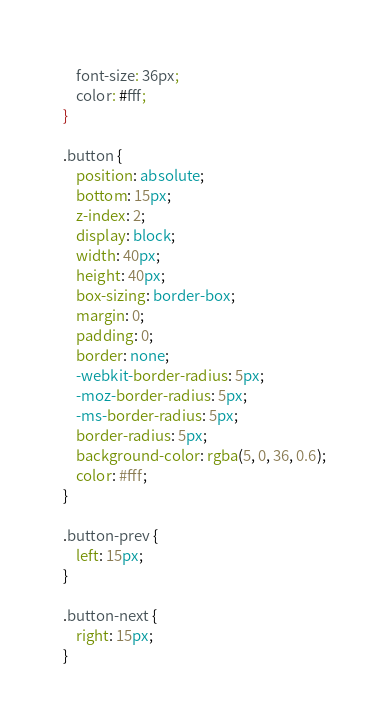Convert code to text. <code><loc_0><loc_0><loc_500><loc_500><_CSS_>	font-size: 36px;
	color: #fff;
}

.button {
	position: absolute;
	bottom: 15px;
	z-index: 2;
	display: block;
	width: 40px;
	height: 40px;
	box-sizing: border-box;
	margin: 0;
	padding: 0;
	border: none;
	-webkit-border-radius: 5px;
    -moz-border-radius: 5px;
    -ms-border-radius: 5px;
    border-radius: 5px;
	background-color: rgba(5, 0, 36, 0.6);
	color: #fff;
}

.button-prev {
	left: 15px;
}

.button-next {
	right: 15px;
}</code> 